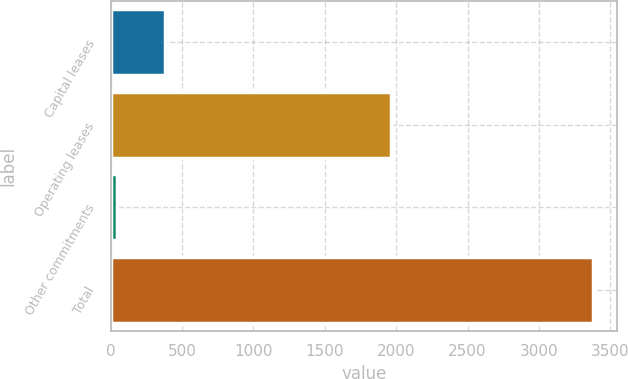Convert chart to OTSL. <chart><loc_0><loc_0><loc_500><loc_500><bar_chart><fcel>Capital leases<fcel>Operating leases<fcel>Other commitments<fcel>Total<nl><fcel>379.5<fcel>1962.5<fcel>46.1<fcel>3380.1<nl></chart> 